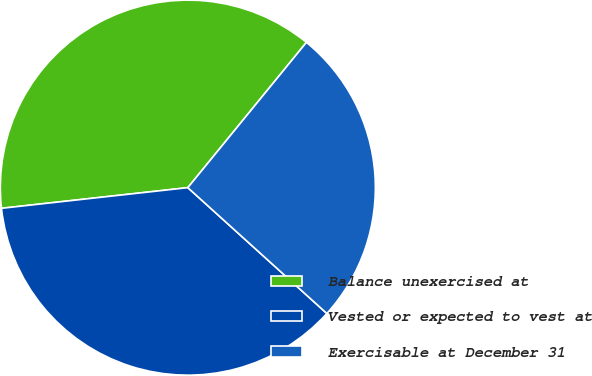Convert chart to OTSL. <chart><loc_0><loc_0><loc_500><loc_500><pie_chart><fcel>Balance unexercised at<fcel>Vested or expected to vest at<fcel>Exercisable at December 31<nl><fcel>37.65%<fcel>36.53%<fcel>25.81%<nl></chart> 